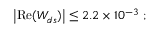Convert formula to latex. <formula><loc_0><loc_0><loc_500><loc_500>\left | R e ( W _ { d s } ) \right | \leq 2 . 2 \times 1 0 ^ { - 3 } ;</formula> 